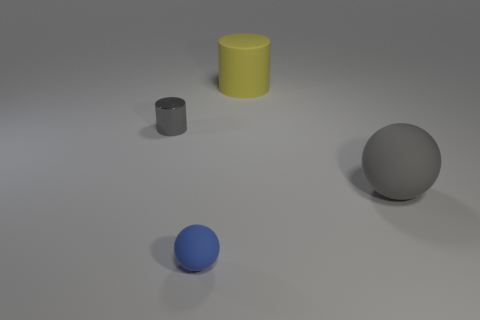Add 4 purple cylinders. How many objects exist? 8 Subtract all blue matte things. Subtract all big brown matte spheres. How many objects are left? 3 Add 4 large gray balls. How many large gray balls are left? 5 Add 1 big yellow rubber spheres. How many big yellow rubber spheres exist? 1 Subtract 0 cyan cubes. How many objects are left? 4 